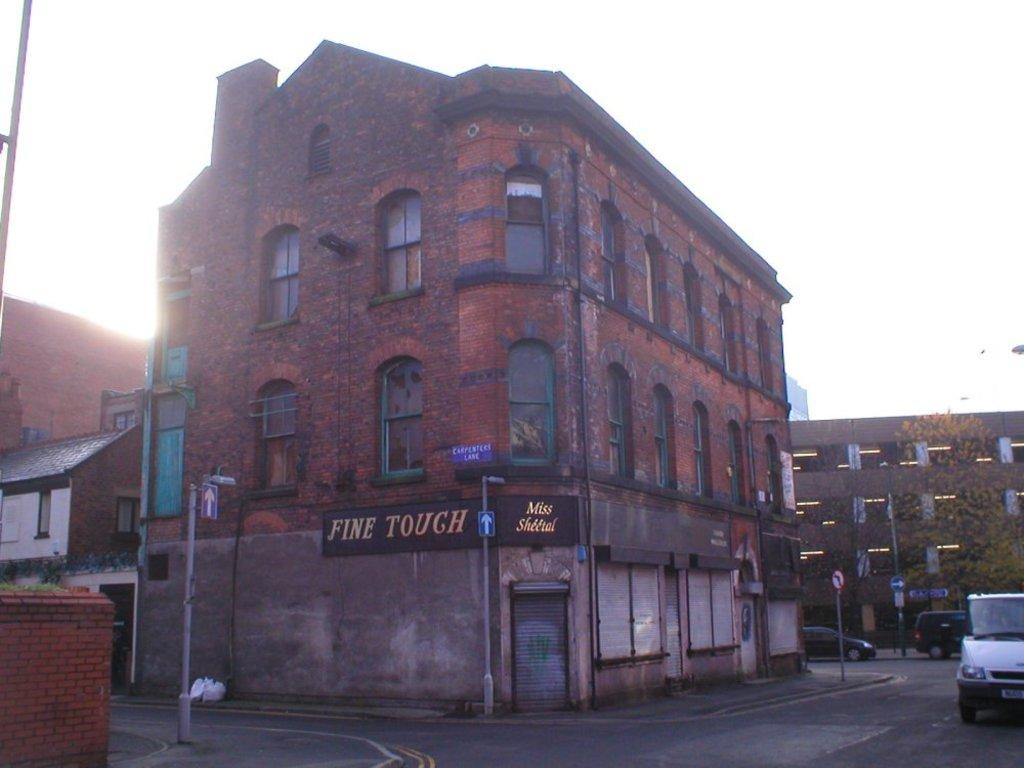What objects can be seen in the image that are related to construction or infrastructure? In the image, there are boards and poles that are related to construction or infrastructure. What objects in the image provide illumination? There are lights in the image that provide illumination. What type of transportation is visible in the image? There are vehicles on the road in the image. What type of structures can be seen in the image? There are buildings in the image. What type of vegetation is present in the image? There is a tree in the image. What can be seen in the background of the image? The sky is visible in the background of the image. How many bananas are hanging from the tree in the image? There are no bananas present in the image; it features a tree without any fruit. What time is displayed on the clock in the image? There is no clock present in the image. 